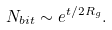<formula> <loc_0><loc_0><loc_500><loc_500>N _ { b i t } \sim e ^ { t / 2 R _ { g } } .</formula> 